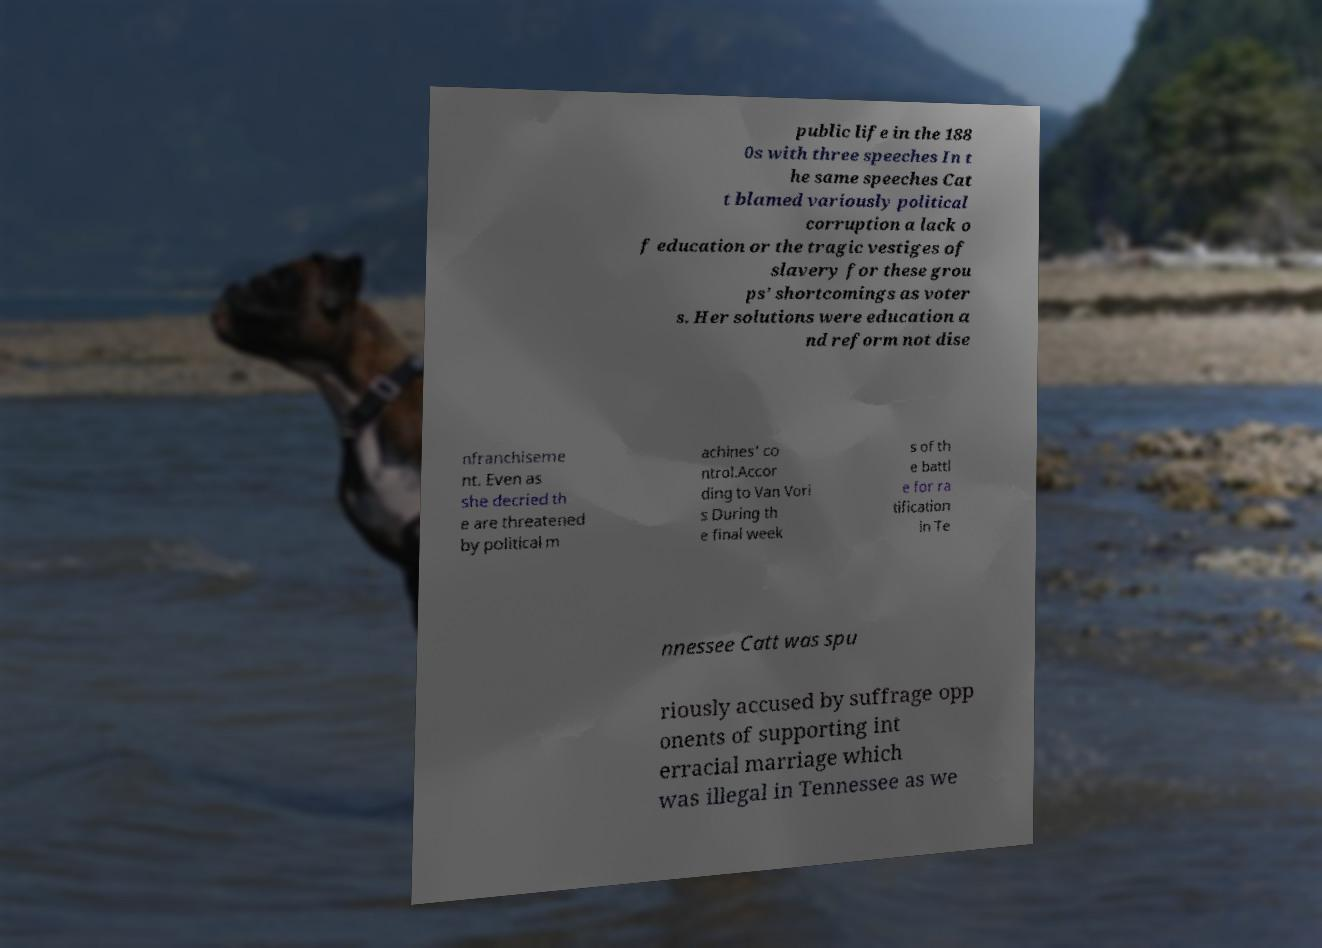What messages or text are displayed in this image? I need them in a readable, typed format. public life in the 188 0s with three speeches In t he same speeches Cat t blamed variously political corruption a lack o f education or the tragic vestiges of slavery for these grou ps’ shortcomings as voter s. Her solutions were education a nd reform not dise nfranchiseme nt. Even as she decried th e are threatened by political m achines' co ntrol.Accor ding to Van Vori s During th e final week s of th e battl e for ra tification in Te nnessee Catt was spu riously accused by suffrage opp onents of supporting int erracial marriage which was illegal in Tennessee as we 